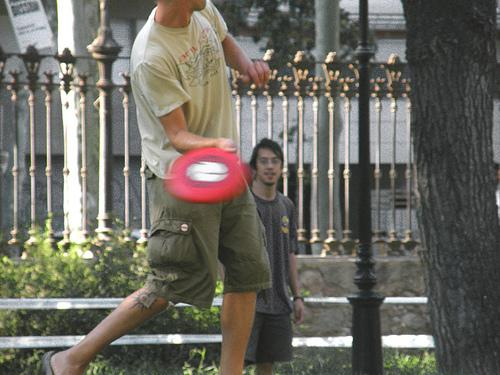What is tattooed on his right leg? Please explain your reasoning. heart. A heart is tattooed on. 